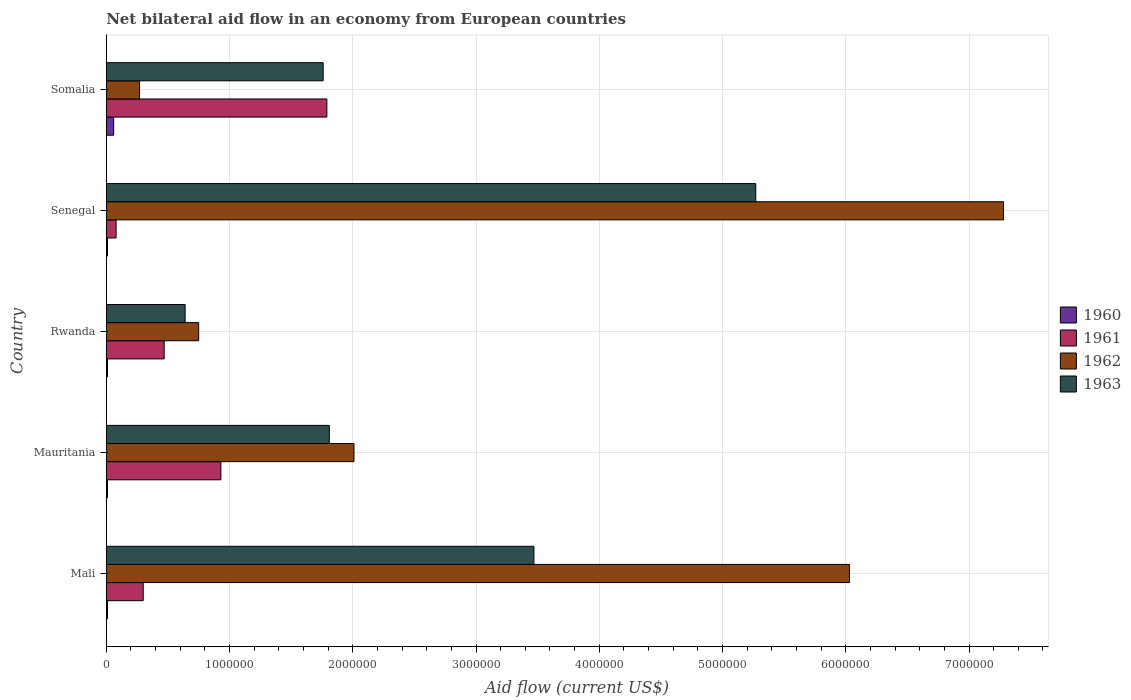Are the number of bars per tick equal to the number of legend labels?
Your response must be concise. Yes. Are the number of bars on each tick of the Y-axis equal?
Offer a terse response. Yes. How many bars are there on the 2nd tick from the bottom?
Your response must be concise. 4. What is the label of the 1st group of bars from the top?
Your answer should be compact. Somalia. What is the net bilateral aid flow in 1960 in Senegal?
Ensure brevity in your answer.  10000. Across all countries, what is the maximum net bilateral aid flow in 1960?
Provide a short and direct response. 6.00e+04. In which country was the net bilateral aid flow in 1960 maximum?
Provide a short and direct response. Somalia. In which country was the net bilateral aid flow in 1962 minimum?
Offer a terse response. Somalia. What is the total net bilateral aid flow in 1963 in the graph?
Your answer should be compact. 1.30e+07. What is the difference between the net bilateral aid flow in 1962 in Rwanda and the net bilateral aid flow in 1963 in Mauritania?
Keep it short and to the point. -1.06e+06. What is the average net bilateral aid flow in 1963 per country?
Your response must be concise. 2.59e+06. What is the difference between the net bilateral aid flow in 1963 and net bilateral aid flow in 1962 in Somalia?
Make the answer very short. 1.49e+06. In how many countries, is the net bilateral aid flow in 1960 greater than 400000 US$?
Keep it short and to the point. 0. What is the ratio of the net bilateral aid flow in 1961 in Mali to that in Mauritania?
Your response must be concise. 0.32. Is the net bilateral aid flow in 1960 in Mali less than that in Rwanda?
Your response must be concise. No. What is the difference between the highest and the lowest net bilateral aid flow in 1960?
Your answer should be very brief. 5.00e+04. Is the sum of the net bilateral aid flow in 1963 in Mali and Senegal greater than the maximum net bilateral aid flow in 1962 across all countries?
Make the answer very short. Yes. Is it the case that in every country, the sum of the net bilateral aid flow in 1960 and net bilateral aid flow in 1961 is greater than the sum of net bilateral aid flow in 1963 and net bilateral aid flow in 1962?
Offer a very short reply. No. What does the 4th bar from the bottom in Senegal represents?
Offer a very short reply. 1963. Is it the case that in every country, the sum of the net bilateral aid flow in 1960 and net bilateral aid flow in 1962 is greater than the net bilateral aid flow in 1961?
Offer a terse response. No. Are all the bars in the graph horizontal?
Provide a succinct answer. Yes. What is the difference between two consecutive major ticks on the X-axis?
Give a very brief answer. 1.00e+06. Are the values on the major ticks of X-axis written in scientific E-notation?
Make the answer very short. No. Does the graph contain any zero values?
Ensure brevity in your answer.  No. Where does the legend appear in the graph?
Your response must be concise. Center right. How many legend labels are there?
Give a very brief answer. 4. What is the title of the graph?
Provide a short and direct response. Net bilateral aid flow in an economy from European countries. What is the label or title of the X-axis?
Offer a very short reply. Aid flow (current US$). What is the Aid flow (current US$) in 1960 in Mali?
Give a very brief answer. 10000. What is the Aid flow (current US$) in 1962 in Mali?
Offer a terse response. 6.03e+06. What is the Aid flow (current US$) of 1963 in Mali?
Keep it short and to the point. 3.47e+06. What is the Aid flow (current US$) of 1961 in Mauritania?
Offer a very short reply. 9.30e+05. What is the Aid flow (current US$) of 1962 in Mauritania?
Offer a terse response. 2.01e+06. What is the Aid flow (current US$) of 1963 in Mauritania?
Offer a very short reply. 1.81e+06. What is the Aid flow (current US$) in 1962 in Rwanda?
Provide a short and direct response. 7.50e+05. What is the Aid flow (current US$) of 1963 in Rwanda?
Your response must be concise. 6.40e+05. What is the Aid flow (current US$) in 1962 in Senegal?
Make the answer very short. 7.28e+06. What is the Aid flow (current US$) in 1963 in Senegal?
Provide a succinct answer. 5.27e+06. What is the Aid flow (current US$) in 1960 in Somalia?
Your answer should be very brief. 6.00e+04. What is the Aid flow (current US$) in 1961 in Somalia?
Offer a terse response. 1.79e+06. What is the Aid flow (current US$) of 1963 in Somalia?
Your answer should be compact. 1.76e+06. Across all countries, what is the maximum Aid flow (current US$) of 1961?
Keep it short and to the point. 1.79e+06. Across all countries, what is the maximum Aid flow (current US$) in 1962?
Your answer should be very brief. 7.28e+06. Across all countries, what is the maximum Aid flow (current US$) in 1963?
Ensure brevity in your answer.  5.27e+06. Across all countries, what is the minimum Aid flow (current US$) in 1960?
Your answer should be very brief. 10000. Across all countries, what is the minimum Aid flow (current US$) in 1963?
Your answer should be very brief. 6.40e+05. What is the total Aid flow (current US$) of 1961 in the graph?
Ensure brevity in your answer.  3.57e+06. What is the total Aid flow (current US$) in 1962 in the graph?
Give a very brief answer. 1.63e+07. What is the total Aid flow (current US$) of 1963 in the graph?
Your answer should be very brief. 1.30e+07. What is the difference between the Aid flow (current US$) of 1960 in Mali and that in Mauritania?
Provide a short and direct response. 0. What is the difference between the Aid flow (current US$) of 1961 in Mali and that in Mauritania?
Your answer should be compact. -6.30e+05. What is the difference between the Aid flow (current US$) in 1962 in Mali and that in Mauritania?
Your response must be concise. 4.02e+06. What is the difference between the Aid flow (current US$) in 1963 in Mali and that in Mauritania?
Provide a short and direct response. 1.66e+06. What is the difference between the Aid flow (current US$) of 1960 in Mali and that in Rwanda?
Offer a very short reply. 0. What is the difference between the Aid flow (current US$) of 1961 in Mali and that in Rwanda?
Give a very brief answer. -1.70e+05. What is the difference between the Aid flow (current US$) of 1962 in Mali and that in Rwanda?
Offer a terse response. 5.28e+06. What is the difference between the Aid flow (current US$) of 1963 in Mali and that in Rwanda?
Offer a terse response. 2.83e+06. What is the difference between the Aid flow (current US$) of 1962 in Mali and that in Senegal?
Give a very brief answer. -1.25e+06. What is the difference between the Aid flow (current US$) in 1963 in Mali and that in Senegal?
Offer a very short reply. -1.80e+06. What is the difference between the Aid flow (current US$) in 1961 in Mali and that in Somalia?
Make the answer very short. -1.49e+06. What is the difference between the Aid flow (current US$) of 1962 in Mali and that in Somalia?
Provide a succinct answer. 5.76e+06. What is the difference between the Aid flow (current US$) in 1963 in Mali and that in Somalia?
Provide a short and direct response. 1.71e+06. What is the difference between the Aid flow (current US$) of 1961 in Mauritania and that in Rwanda?
Keep it short and to the point. 4.60e+05. What is the difference between the Aid flow (current US$) of 1962 in Mauritania and that in Rwanda?
Give a very brief answer. 1.26e+06. What is the difference between the Aid flow (current US$) of 1963 in Mauritania and that in Rwanda?
Offer a very short reply. 1.17e+06. What is the difference between the Aid flow (current US$) of 1960 in Mauritania and that in Senegal?
Offer a very short reply. 0. What is the difference between the Aid flow (current US$) of 1961 in Mauritania and that in Senegal?
Offer a very short reply. 8.50e+05. What is the difference between the Aid flow (current US$) in 1962 in Mauritania and that in Senegal?
Ensure brevity in your answer.  -5.27e+06. What is the difference between the Aid flow (current US$) in 1963 in Mauritania and that in Senegal?
Your response must be concise. -3.46e+06. What is the difference between the Aid flow (current US$) in 1961 in Mauritania and that in Somalia?
Provide a succinct answer. -8.60e+05. What is the difference between the Aid flow (current US$) in 1962 in Mauritania and that in Somalia?
Provide a succinct answer. 1.74e+06. What is the difference between the Aid flow (current US$) of 1961 in Rwanda and that in Senegal?
Your response must be concise. 3.90e+05. What is the difference between the Aid flow (current US$) of 1962 in Rwanda and that in Senegal?
Your answer should be compact. -6.53e+06. What is the difference between the Aid flow (current US$) of 1963 in Rwanda and that in Senegal?
Your answer should be very brief. -4.63e+06. What is the difference between the Aid flow (current US$) in 1960 in Rwanda and that in Somalia?
Make the answer very short. -5.00e+04. What is the difference between the Aid flow (current US$) of 1961 in Rwanda and that in Somalia?
Provide a succinct answer. -1.32e+06. What is the difference between the Aid flow (current US$) in 1963 in Rwanda and that in Somalia?
Ensure brevity in your answer.  -1.12e+06. What is the difference between the Aid flow (current US$) of 1961 in Senegal and that in Somalia?
Your response must be concise. -1.71e+06. What is the difference between the Aid flow (current US$) of 1962 in Senegal and that in Somalia?
Your response must be concise. 7.01e+06. What is the difference between the Aid flow (current US$) of 1963 in Senegal and that in Somalia?
Provide a short and direct response. 3.51e+06. What is the difference between the Aid flow (current US$) in 1960 in Mali and the Aid flow (current US$) in 1961 in Mauritania?
Provide a short and direct response. -9.20e+05. What is the difference between the Aid flow (current US$) of 1960 in Mali and the Aid flow (current US$) of 1963 in Mauritania?
Your answer should be compact. -1.80e+06. What is the difference between the Aid flow (current US$) of 1961 in Mali and the Aid flow (current US$) of 1962 in Mauritania?
Your response must be concise. -1.71e+06. What is the difference between the Aid flow (current US$) of 1961 in Mali and the Aid flow (current US$) of 1963 in Mauritania?
Offer a very short reply. -1.51e+06. What is the difference between the Aid flow (current US$) of 1962 in Mali and the Aid flow (current US$) of 1963 in Mauritania?
Ensure brevity in your answer.  4.22e+06. What is the difference between the Aid flow (current US$) in 1960 in Mali and the Aid flow (current US$) in 1961 in Rwanda?
Your answer should be compact. -4.60e+05. What is the difference between the Aid flow (current US$) of 1960 in Mali and the Aid flow (current US$) of 1962 in Rwanda?
Your response must be concise. -7.40e+05. What is the difference between the Aid flow (current US$) of 1960 in Mali and the Aid flow (current US$) of 1963 in Rwanda?
Offer a very short reply. -6.30e+05. What is the difference between the Aid flow (current US$) in 1961 in Mali and the Aid flow (current US$) in 1962 in Rwanda?
Your answer should be very brief. -4.50e+05. What is the difference between the Aid flow (current US$) of 1961 in Mali and the Aid flow (current US$) of 1963 in Rwanda?
Ensure brevity in your answer.  -3.40e+05. What is the difference between the Aid flow (current US$) of 1962 in Mali and the Aid flow (current US$) of 1963 in Rwanda?
Ensure brevity in your answer.  5.39e+06. What is the difference between the Aid flow (current US$) in 1960 in Mali and the Aid flow (current US$) in 1961 in Senegal?
Your response must be concise. -7.00e+04. What is the difference between the Aid flow (current US$) in 1960 in Mali and the Aid flow (current US$) in 1962 in Senegal?
Ensure brevity in your answer.  -7.27e+06. What is the difference between the Aid flow (current US$) in 1960 in Mali and the Aid flow (current US$) in 1963 in Senegal?
Provide a succinct answer. -5.26e+06. What is the difference between the Aid flow (current US$) of 1961 in Mali and the Aid flow (current US$) of 1962 in Senegal?
Provide a succinct answer. -6.98e+06. What is the difference between the Aid flow (current US$) in 1961 in Mali and the Aid flow (current US$) in 1963 in Senegal?
Offer a very short reply. -4.97e+06. What is the difference between the Aid flow (current US$) in 1962 in Mali and the Aid flow (current US$) in 1963 in Senegal?
Your answer should be compact. 7.60e+05. What is the difference between the Aid flow (current US$) in 1960 in Mali and the Aid flow (current US$) in 1961 in Somalia?
Provide a succinct answer. -1.78e+06. What is the difference between the Aid flow (current US$) of 1960 in Mali and the Aid flow (current US$) of 1962 in Somalia?
Offer a very short reply. -2.60e+05. What is the difference between the Aid flow (current US$) of 1960 in Mali and the Aid flow (current US$) of 1963 in Somalia?
Offer a terse response. -1.75e+06. What is the difference between the Aid flow (current US$) of 1961 in Mali and the Aid flow (current US$) of 1962 in Somalia?
Your response must be concise. 3.00e+04. What is the difference between the Aid flow (current US$) in 1961 in Mali and the Aid flow (current US$) in 1963 in Somalia?
Keep it short and to the point. -1.46e+06. What is the difference between the Aid flow (current US$) in 1962 in Mali and the Aid flow (current US$) in 1963 in Somalia?
Provide a short and direct response. 4.27e+06. What is the difference between the Aid flow (current US$) of 1960 in Mauritania and the Aid flow (current US$) of 1961 in Rwanda?
Keep it short and to the point. -4.60e+05. What is the difference between the Aid flow (current US$) of 1960 in Mauritania and the Aid flow (current US$) of 1962 in Rwanda?
Your response must be concise. -7.40e+05. What is the difference between the Aid flow (current US$) of 1960 in Mauritania and the Aid flow (current US$) of 1963 in Rwanda?
Keep it short and to the point. -6.30e+05. What is the difference between the Aid flow (current US$) of 1961 in Mauritania and the Aid flow (current US$) of 1963 in Rwanda?
Your answer should be very brief. 2.90e+05. What is the difference between the Aid flow (current US$) of 1962 in Mauritania and the Aid flow (current US$) of 1963 in Rwanda?
Your response must be concise. 1.37e+06. What is the difference between the Aid flow (current US$) in 1960 in Mauritania and the Aid flow (current US$) in 1961 in Senegal?
Your answer should be compact. -7.00e+04. What is the difference between the Aid flow (current US$) of 1960 in Mauritania and the Aid flow (current US$) of 1962 in Senegal?
Make the answer very short. -7.27e+06. What is the difference between the Aid flow (current US$) of 1960 in Mauritania and the Aid flow (current US$) of 1963 in Senegal?
Make the answer very short. -5.26e+06. What is the difference between the Aid flow (current US$) of 1961 in Mauritania and the Aid flow (current US$) of 1962 in Senegal?
Offer a very short reply. -6.35e+06. What is the difference between the Aid flow (current US$) of 1961 in Mauritania and the Aid flow (current US$) of 1963 in Senegal?
Make the answer very short. -4.34e+06. What is the difference between the Aid flow (current US$) in 1962 in Mauritania and the Aid flow (current US$) in 1963 in Senegal?
Offer a terse response. -3.26e+06. What is the difference between the Aid flow (current US$) of 1960 in Mauritania and the Aid flow (current US$) of 1961 in Somalia?
Your response must be concise. -1.78e+06. What is the difference between the Aid flow (current US$) of 1960 in Mauritania and the Aid flow (current US$) of 1962 in Somalia?
Ensure brevity in your answer.  -2.60e+05. What is the difference between the Aid flow (current US$) of 1960 in Mauritania and the Aid flow (current US$) of 1963 in Somalia?
Offer a very short reply. -1.75e+06. What is the difference between the Aid flow (current US$) in 1961 in Mauritania and the Aid flow (current US$) in 1963 in Somalia?
Provide a short and direct response. -8.30e+05. What is the difference between the Aid flow (current US$) of 1962 in Mauritania and the Aid flow (current US$) of 1963 in Somalia?
Your response must be concise. 2.50e+05. What is the difference between the Aid flow (current US$) of 1960 in Rwanda and the Aid flow (current US$) of 1962 in Senegal?
Give a very brief answer. -7.27e+06. What is the difference between the Aid flow (current US$) in 1960 in Rwanda and the Aid flow (current US$) in 1963 in Senegal?
Your response must be concise. -5.26e+06. What is the difference between the Aid flow (current US$) of 1961 in Rwanda and the Aid flow (current US$) of 1962 in Senegal?
Provide a succinct answer. -6.81e+06. What is the difference between the Aid flow (current US$) of 1961 in Rwanda and the Aid flow (current US$) of 1963 in Senegal?
Your answer should be compact. -4.80e+06. What is the difference between the Aid flow (current US$) of 1962 in Rwanda and the Aid flow (current US$) of 1963 in Senegal?
Offer a terse response. -4.52e+06. What is the difference between the Aid flow (current US$) in 1960 in Rwanda and the Aid flow (current US$) in 1961 in Somalia?
Offer a very short reply. -1.78e+06. What is the difference between the Aid flow (current US$) in 1960 in Rwanda and the Aid flow (current US$) in 1963 in Somalia?
Give a very brief answer. -1.75e+06. What is the difference between the Aid flow (current US$) of 1961 in Rwanda and the Aid flow (current US$) of 1963 in Somalia?
Keep it short and to the point. -1.29e+06. What is the difference between the Aid flow (current US$) of 1962 in Rwanda and the Aid flow (current US$) of 1963 in Somalia?
Offer a very short reply. -1.01e+06. What is the difference between the Aid flow (current US$) in 1960 in Senegal and the Aid flow (current US$) in 1961 in Somalia?
Provide a short and direct response. -1.78e+06. What is the difference between the Aid flow (current US$) of 1960 in Senegal and the Aid flow (current US$) of 1962 in Somalia?
Make the answer very short. -2.60e+05. What is the difference between the Aid flow (current US$) in 1960 in Senegal and the Aid flow (current US$) in 1963 in Somalia?
Offer a terse response. -1.75e+06. What is the difference between the Aid flow (current US$) in 1961 in Senegal and the Aid flow (current US$) in 1962 in Somalia?
Keep it short and to the point. -1.90e+05. What is the difference between the Aid flow (current US$) of 1961 in Senegal and the Aid flow (current US$) of 1963 in Somalia?
Provide a succinct answer. -1.68e+06. What is the difference between the Aid flow (current US$) in 1962 in Senegal and the Aid flow (current US$) in 1963 in Somalia?
Your answer should be very brief. 5.52e+06. What is the average Aid flow (current US$) in 1961 per country?
Give a very brief answer. 7.14e+05. What is the average Aid flow (current US$) in 1962 per country?
Your answer should be very brief. 3.27e+06. What is the average Aid flow (current US$) in 1963 per country?
Offer a terse response. 2.59e+06. What is the difference between the Aid flow (current US$) in 1960 and Aid flow (current US$) in 1962 in Mali?
Ensure brevity in your answer.  -6.02e+06. What is the difference between the Aid flow (current US$) of 1960 and Aid flow (current US$) of 1963 in Mali?
Offer a very short reply. -3.46e+06. What is the difference between the Aid flow (current US$) of 1961 and Aid flow (current US$) of 1962 in Mali?
Your response must be concise. -5.73e+06. What is the difference between the Aid flow (current US$) in 1961 and Aid flow (current US$) in 1963 in Mali?
Offer a terse response. -3.17e+06. What is the difference between the Aid flow (current US$) in 1962 and Aid flow (current US$) in 1963 in Mali?
Provide a short and direct response. 2.56e+06. What is the difference between the Aid flow (current US$) of 1960 and Aid flow (current US$) of 1961 in Mauritania?
Provide a succinct answer. -9.20e+05. What is the difference between the Aid flow (current US$) in 1960 and Aid flow (current US$) in 1963 in Mauritania?
Your answer should be compact. -1.80e+06. What is the difference between the Aid flow (current US$) of 1961 and Aid flow (current US$) of 1962 in Mauritania?
Offer a terse response. -1.08e+06. What is the difference between the Aid flow (current US$) of 1961 and Aid flow (current US$) of 1963 in Mauritania?
Give a very brief answer. -8.80e+05. What is the difference between the Aid flow (current US$) in 1962 and Aid flow (current US$) in 1963 in Mauritania?
Keep it short and to the point. 2.00e+05. What is the difference between the Aid flow (current US$) of 1960 and Aid flow (current US$) of 1961 in Rwanda?
Give a very brief answer. -4.60e+05. What is the difference between the Aid flow (current US$) of 1960 and Aid flow (current US$) of 1962 in Rwanda?
Give a very brief answer. -7.40e+05. What is the difference between the Aid flow (current US$) in 1960 and Aid flow (current US$) in 1963 in Rwanda?
Make the answer very short. -6.30e+05. What is the difference between the Aid flow (current US$) of 1961 and Aid flow (current US$) of 1962 in Rwanda?
Offer a terse response. -2.80e+05. What is the difference between the Aid flow (current US$) of 1960 and Aid flow (current US$) of 1961 in Senegal?
Give a very brief answer. -7.00e+04. What is the difference between the Aid flow (current US$) in 1960 and Aid flow (current US$) in 1962 in Senegal?
Give a very brief answer. -7.27e+06. What is the difference between the Aid flow (current US$) of 1960 and Aid flow (current US$) of 1963 in Senegal?
Ensure brevity in your answer.  -5.26e+06. What is the difference between the Aid flow (current US$) in 1961 and Aid flow (current US$) in 1962 in Senegal?
Offer a terse response. -7.20e+06. What is the difference between the Aid flow (current US$) of 1961 and Aid flow (current US$) of 1963 in Senegal?
Keep it short and to the point. -5.19e+06. What is the difference between the Aid flow (current US$) in 1962 and Aid flow (current US$) in 1963 in Senegal?
Keep it short and to the point. 2.01e+06. What is the difference between the Aid flow (current US$) of 1960 and Aid flow (current US$) of 1961 in Somalia?
Ensure brevity in your answer.  -1.73e+06. What is the difference between the Aid flow (current US$) of 1960 and Aid flow (current US$) of 1962 in Somalia?
Provide a succinct answer. -2.10e+05. What is the difference between the Aid flow (current US$) in 1960 and Aid flow (current US$) in 1963 in Somalia?
Make the answer very short. -1.70e+06. What is the difference between the Aid flow (current US$) in 1961 and Aid flow (current US$) in 1962 in Somalia?
Provide a short and direct response. 1.52e+06. What is the difference between the Aid flow (current US$) in 1962 and Aid flow (current US$) in 1963 in Somalia?
Offer a terse response. -1.49e+06. What is the ratio of the Aid flow (current US$) in 1960 in Mali to that in Mauritania?
Your answer should be very brief. 1. What is the ratio of the Aid flow (current US$) in 1961 in Mali to that in Mauritania?
Your answer should be compact. 0.32. What is the ratio of the Aid flow (current US$) in 1962 in Mali to that in Mauritania?
Provide a succinct answer. 3. What is the ratio of the Aid flow (current US$) of 1963 in Mali to that in Mauritania?
Your answer should be compact. 1.92. What is the ratio of the Aid flow (current US$) of 1961 in Mali to that in Rwanda?
Your answer should be very brief. 0.64. What is the ratio of the Aid flow (current US$) of 1962 in Mali to that in Rwanda?
Your answer should be compact. 8.04. What is the ratio of the Aid flow (current US$) in 1963 in Mali to that in Rwanda?
Offer a terse response. 5.42. What is the ratio of the Aid flow (current US$) in 1961 in Mali to that in Senegal?
Offer a terse response. 3.75. What is the ratio of the Aid flow (current US$) of 1962 in Mali to that in Senegal?
Offer a terse response. 0.83. What is the ratio of the Aid flow (current US$) in 1963 in Mali to that in Senegal?
Provide a short and direct response. 0.66. What is the ratio of the Aid flow (current US$) in 1961 in Mali to that in Somalia?
Your answer should be compact. 0.17. What is the ratio of the Aid flow (current US$) of 1962 in Mali to that in Somalia?
Offer a very short reply. 22.33. What is the ratio of the Aid flow (current US$) in 1963 in Mali to that in Somalia?
Keep it short and to the point. 1.97. What is the ratio of the Aid flow (current US$) of 1961 in Mauritania to that in Rwanda?
Give a very brief answer. 1.98. What is the ratio of the Aid flow (current US$) in 1962 in Mauritania to that in Rwanda?
Provide a succinct answer. 2.68. What is the ratio of the Aid flow (current US$) in 1963 in Mauritania to that in Rwanda?
Give a very brief answer. 2.83. What is the ratio of the Aid flow (current US$) of 1960 in Mauritania to that in Senegal?
Your response must be concise. 1. What is the ratio of the Aid flow (current US$) in 1961 in Mauritania to that in Senegal?
Make the answer very short. 11.62. What is the ratio of the Aid flow (current US$) of 1962 in Mauritania to that in Senegal?
Your answer should be compact. 0.28. What is the ratio of the Aid flow (current US$) in 1963 in Mauritania to that in Senegal?
Give a very brief answer. 0.34. What is the ratio of the Aid flow (current US$) in 1961 in Mauritania to that in Somalia?
Offer a terse response. 0.52. What is the ratio of the Aid flow (current US$) of 1962 in Mauritania to that in Somalia?
Give a very brief answer. 7.44. What is the ratio of the Aid flow (current US$) in 1963 in Mauritania to that in Somalia?
Offer a terse response. 1.03. What is the ratio of the Aid flow (current US$) of 1961 in Rwanda to that in Senegal?
Offer a very short reply. 5.88. What is the ratio of the Aid flow (current US$) of 1962 in Rwanda to that in Senegal?
Ensure brevity in your answer.  0.1. What is the ratio of the Aid flow (current US$) in 1963 in Rwanda to that in Senegal?
Keep it short and to the point. 0.12. What is the ratio of the Aid flow (current US$) of 1961 in Rwanda to that in Somalia?
Provide a short and direct response. 0.26. What is the ratio of the Aid flow (current US$) in 1962 in Rwanda to that in Somalia?
Your answer should be very brief. 2.78. What is the ratio of the Aid flow (current US$) in 1963 in Rwanda to that in Somalia?
Offer a very short reply. 0.36. What is the ratio of the Aid flow (current US$) in 1960 in Senegal to that in Somalia?
Offer a very short reply. 0.17. What is the ratio of the Aid flow (current US$) in 1961 in Senegal to that in Somalia?
Offer a very short reply. 0.04. What is the ratio of the Aid flow (current US$) of 1962 in Senegal to that in Somalia?
Provide a succinct answer. 26.96. What is the ratio of the Aid flow (current US$) of 1963 in Senegal to that in Somalia?
Your answer should be compact. 2.99. What is the difference between the highest and the second highest Aid flow (current US$) in 1961?
Your response must be concise. 8.60e+05. What is the difference between the highest and the second highest Aid flow (current US$) in 1962?
Offer a terse response. 1.25e+06. What is the difference between the highest and the second highest Aid flow (current US$) in 1963?
Offer a very short reply. 1.80e+06. What is the difference between the highest and the lowest Aid flow (current US$) of 1960?
Ensure brevity in your answer.  5.00e+04. What is the difference between the highest and the lowest Aid flow (current US$) of 1961?
Make the answer very short. 1.71e+06. What is the difference between the highest and the lowest Aid flow (current US$) of 1962?
Keep it short and to the point. 7.01e+06. What is the difference between the highest and the lowest Aid flow (current US$) in 1963?
Keep it short and to the point. 4.63e+06. 